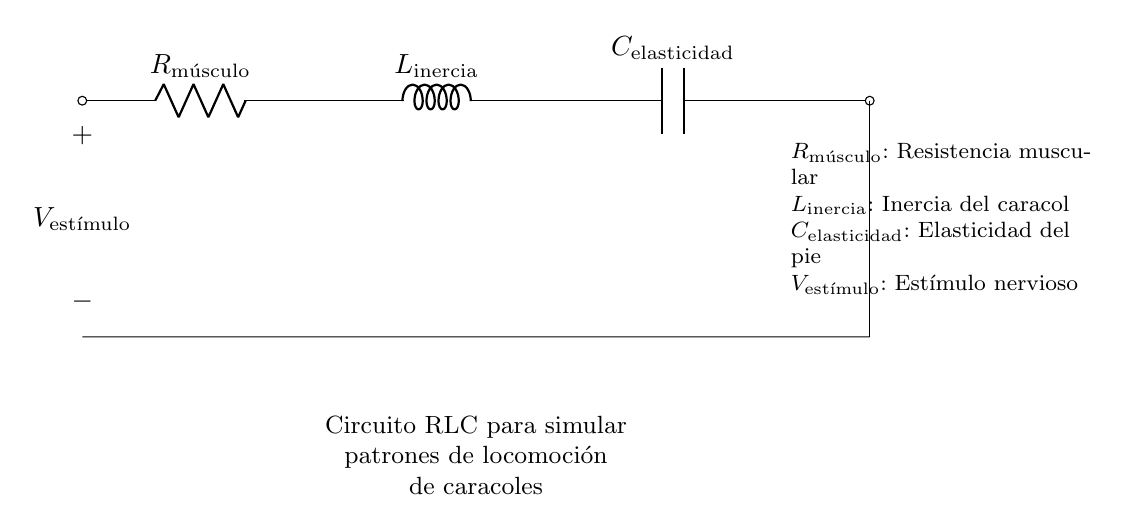¿Qué componentes presenta el circuito? El circuito presenta un resistor, un inductor y un condensador. Estos son los componentes fundamentales que constituyen un circuito RLC.
Answer: resistor, inductor, condensador ¿Cuál es la función del resistor en este circuito? La función del resistor es controlar la corriente que fluye a través del circuito, representando la resistencia muscular del caracol.
Answer: controlar la corriente ¿Qué representa el inductor en el contexto del caracol? El inductor representa la inercia del caracol, que es la tendencia a continuar en movimiento debido a su masa y velocidad.
Answer: inercia del caracol ¿Qué variable se aplica como entrada en este circuito? La variable que se aplica como entrada es el estímulo nervioso que activa los músculos del caracol.
Answer: estímulo nervioso ¿Cómo afecta la resistencia al movimiento del caracol en el circuito? La resistencia limita la cantidad de corriente que puede pasar por el circuito, afectando la velocidad y eficiencia del movimiento del caracol, ya que una mayor resistencia resulta en menor velocidad.
Answer: limita la corriente ¿Qué relación se puede establecer entre la capacitancia y la elasticidad en el pie del caracol? La capacitancia del circuito representa la capacidad del pie del caracol para almacenar energía elástica, lo que se traduce en la capacidad de moverse durante la locomoción.
Answer: energía elástica ¿Cómo se relacionan los tres elementos en este circuito (resistor, inductor, capacitor)? Los tres elementos interactúan en un RLC para determinar la respuesta dinámica del sistema al estímulo nervioso, afectando la frecuencia y amplitud de la locomoción del caracol.
Answer: interactúan en la respuesta dinámica 